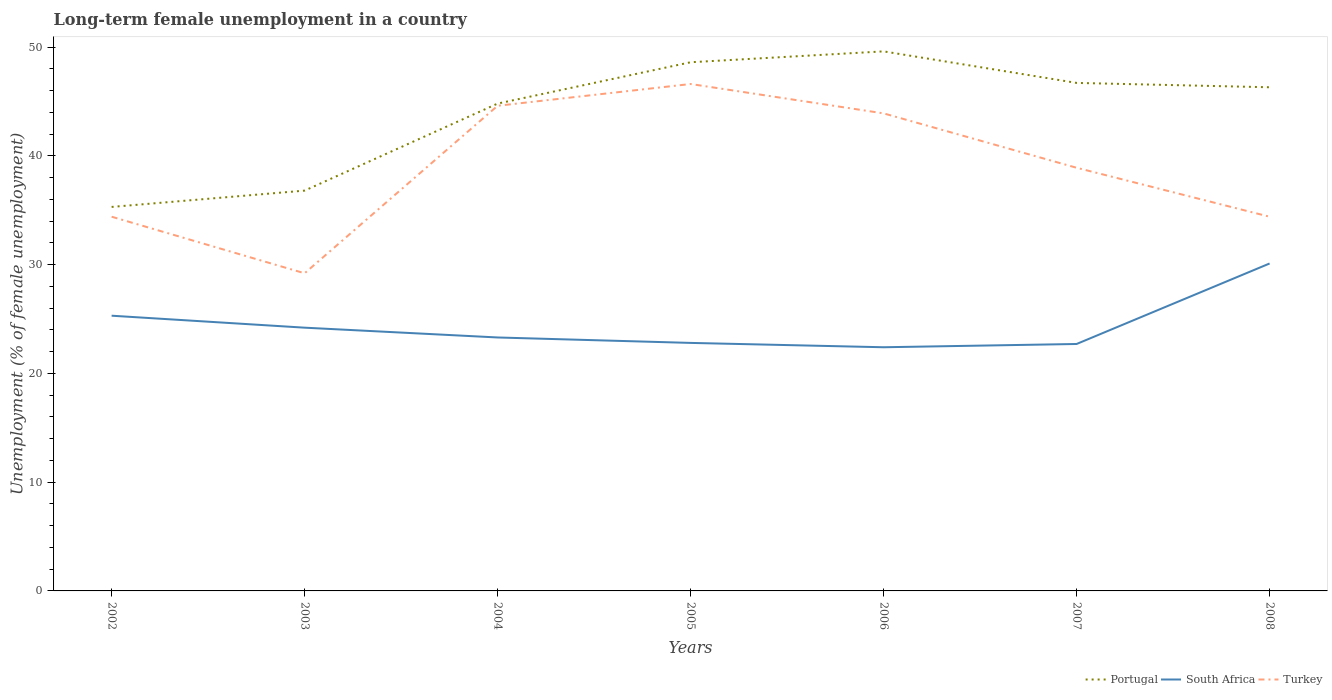Is the number of lines equal to the number of legend labels?
Offer a terse response. Yes. Across all years, what is the maximum percentage of long-term unemployed female population in Portugal?
Offer a terse response. 35.3. In which year was the percentage of long-term unemployed female population in Turkey maximum?
Make the answer very short. 2003. What is the total percentage of long-term unemployed female population in Turkey in the graph?
Keep it short and to the point. 5.7. What is the difference between the highest and the second highest percentage of long-term unemployed female population in South Africa?
Offer a terse response. 7.7. What is the difference between the highest and the lowest percentage of long-term unemployed female population in Turkey?
Offer a terse response. 4. How many lines are there?
Your answer should be very brief. 3. How many years are there in the graph?
Offer a very short reply. 7. What is the difference between two consecutive major ticks on the Y-axis?
Provide a short and direct response. 10. Does the graph contain any zero values?
Your answer should be very brief. No. How are the legend labels stacked?
Give a very brief answer. Horizontal. What is the title of the graph?
Ensure brevity in your answer.  Long-term female unemployment in a country. What is the label or title of the X-axis?
Offer a terse response. Years. What is the label or title of the Y-axis?
Provide a short and direct response. Unemployment (% of female unemployment). What is the Unemployment (% of female unemployment) of Portugal in 2002?
Give a very brief answer. 35.3. What is the Unemployment (% of female unemployment) in South Africa in 2002?
Your answer should be compact. 25.3. What is the Unemployment (% of female unemployment) of Turkey in 2002?
Ensure brevity in your answer.  34.4. What is the Unemployment (% of female unemployment) in Portugal in 2003?
Your answer should be compact. 36.8. What is the Unemployment (% of female unemployment) of South Africa in 2003?
Provide a short and direct response. 24.2. What is the Unemployment (% of female unemployment) in Turkey in 2003?
Provide a succinct answer. 29.2. What is the Unemployment (% of female unemployment) in Portugal in 2004?
Your answer should be compact. 44.8. What is the Unemployment (% of female unemployment) in South Africa in 2004?
Offer a terse response. 23.3. What is the Unemployment (% of female unemployment) of Turkey in 2004?
Provide a succinct answer. 44.6. What is the Unemployment (% of female unemployment) of Portugal in 2005?
Provide a short and direct response. 48.6. What is the Unemployment (% of female unemployment) in South Africa in 2005?
Offer a terse response. 22.8. What is the Unemployment (% of female unemployment) of Turkey in 2005?
Offer a terse response. 46.6. What is the Unemployment (% of female unemployment) of Portugal in 2006?
Your response must be concise. 49.6. What is the Unemployment (% of female unemployment) in South Africa in 2006?
Keep it short and to the point. 22.4. What is the Unemployment (% of female unemployment) in Turkey in 2006?
Keep it short and to the point. 43.9. What is the Unemployment (% of female unemployment) in Portugal in 2007?
Make the answer very short. 46.7. What is the Unemployment (% of female unemployment) in South Africa in 2007?
Your response must be concise. 22.7. What is the Unemployment (% of female unemployment) in Turkey in 2007?
Your answer should be compact. 38.9. What is the Unemployment (% of female unemployment) in Portugal in 2008?
Give a very brief answer. 46.3. What is the Unemployment (% of female unemployment) of South Africa in 2008?
Provide a succinct answer. 30.1. What is the Unemployment (% of female unemployment) in Turkey in 2008?
Give a very brief answer. 34.4. Across all years, what is the maximum Unemployment (% of female unemployment) of Portugal?
Your answer should be compact. 49.6. Across all years, what is the maximum Unemployment (% of female unemployment) of South Africa?
Ensure brevity in your answer.  30.1. Across all years, what is the maximum Unemployment (% of female unemployment) in Turkey?
Your answer should be compact. 46.6. Across all years, what is the minimum Unemployment (% of female unemployment) in Portugal?
Offer a terse response. 35.3. Across all years, what is the minimum Unemployment (% of female unemployment) of South Africa?
Give a very brief answer. 22.4. Across all years, what is the minimum Unemployment (% of female unemployment) in Turkey?
Provide a succinct answer. 29.2. What is the total Unemployment (% of female unemployment) of Portugal in the graph?
Offer a very short reply. 308.1. What is the total Unemployment (% of female unemployment) of South Africa in the graph?
Keep it short and to the point. 170.8. What is the total Unemployment (% of female unemployment) of Turkey in the graph?
Provide a succinct answer. 272. What is the difference between the Unemployment (% of female unemployment) of South Africa in 2002 and that in 2003?
Provide a succinct answer. 1.1. What is the difference between the Unemployment (% of female unemployment) of Turkey in 2002 and that in 2004?
Give a very brief answer. -10.2. What is the difference between the Unemployment (% of female unemployment) in Portugal in 2002 and that in 2005?
Offer a very short reply. -13.3. What is the difference between the Unemployment (% of female unemployment) of South Africa in 2002 and that in 2005?
Ensure brevity in your answer.  2.5. What is the difference between the Unemployment (% of female unemployment) in Portugal in 2002 and that in 2006?
Keep it short and to the point. -14.3. What is the difference between the Unemployment (% of female unemployment) in Portugal in 2002 and that in 2007?
Provide a short and direct response. -11.4. What is the difference between the Unemployment (% of female unemployment) in South Africa in 2002 and that in 2007?
Provide a short and direct response. 2.6. What is the difference between the Unemployment (% of female unemployment) of Turkey in 2002 and that in 2007?
Your response must be concise. -4.5. What is the difference between the Unemployment (% of female unemployment) in South Africa in 2002 and that in 2008?
Your answer should be very brief. -4.8. What is the difference between the Unemployment (% of female unemployment) in South Africa in 2003 and that in 2004?
Give a very brief answer. 0.9. What is the difference between the Unemployment (% of female unemployment) in Turkey in 2003 and that in 2004?
Give a very brief answer. -15.4. What is the difference between the Unemployment (% of female unemployment) in Turkey in 2003 and that in 2005?
Offer a very short reply. -17.4. What is the difference between the Unemployment (% of female unemployment) in Portugal in 2003 and that in 2006?
Give a very brief answer. -12.8. What is the difference between the Unemployment (% of female unemployment) in Turkey in 2003 and that in 2006?
Offer a terse response. -14.7. What is the difference between the Unemployment (% of female unemployment) in Portugal in 2003 and that in 2007?
Provide a succinct answer. -9.9. What is the difference between the Unemployment (% of female unemployment) of South Africa in 2003 and that in 2008?
Give a very brief answer. -5.9. What is the difference between the Unemployment (% of female unemployment) in Turkey in 2003 and that in 2008?
Your answer should be very brief. -5.2. What is the difference between the Unemployment (% of female unemployment) in Portugal in 2004 and that in 2005?
Make the answer very short. -3.8. What is the difference between the Unemployment (% of female unemployment) in Portugal in 2004 and that in 2006?
Provide a succinct answer. -4.8. What is the difference between the Unemployment (% of female unemployment) of Portugal in 2004 and that in 2008?
Make the answer very short. -1.5. What is the difference between the Unemployment (% of female unemployment) of Turkey in 2004 and that in 2008?
Make the answer very short. 10.2. What is the difference between the Unemployment (% of female unemployment) in Portugal in 2005 and that in 2006?
Your response must be concise. -1. What is the difference between the Unemployment (% of female unemployment) in Turkey in 2005 and that in 2006?
Offer a terse response. 2.7. What is the difference between the Unemployment (% of female unemployment) of Portugal in 2005 and that in 2007?
Your answer should be compact. 1.9. What is the difference between the Unemployment (% of female unemployment) in South Africa in 2005 and that in 2007?
Provide a short and direct response. 0.1. What is the difference between the Unemployment (% of female unemployment) of Turkey in 2005 and that in 2007?
Ensure brevity in your answer.  7.7. What is the difference between the Unemployment (% of female unemployment) in South Africa in 2005 and that in 2008?
Make the answer very short. -7.3. What is the difference between the Unemployment (% of female unemployment) of Portugal in 2006 and that in 2007?
Keep it short and to the point. 2.9. What is the difference between the Unemployment (% of female unemployment) in Portugal in 2006 and that in 2008?
Make the answer very short. 3.3. What is the difference between the Unemployment (% of female unemployment) of South Africa in 2006 and that in 2008?
Make the answer very short. -7.7. What is the difference between the Unemployment (% of female unemployment) of Turkey in 2006 and that in 2008?
Give a very brief answer. 9.5. What is the difference between the Unemployment (% of female unemployment) in South Africa in 2007 and that in 2008?
Provide a short and direct response. -7.4. What is the difference between the Unemployment (% of female unemployment) in Turkey in 2007 and that in 2008?
Provide a succinct answer. 4.5. What is the difference between the Unemployment (% of female unemployment) of Portugal in 2002 and the Unemployment (% of female unemployment) of South Africa in 2004?
Ensure brevity in your answer.  12. What is the difference between the Unemployment (% of female unemployment) of Portugal in 2002 and the Unemployment (% of female unemployment) of Turkey in 2004?
Provide a succinct answer. -9.3. What is the difference between the Unemployment (% of female unemployment) of South Africa in 2002 and the Unemployment (% of female unemployment) of Turkey in 2004?
Keep it short and to the point. -19.3. What is the difference between the Unemployment (% of female unemployment) of Portugal in 2002 and the Unemployment (% of female unemployment) of South Africa in 2005?
Provide a short and direct response. 12.5. What is the difference between the Unemployment (% of female unemployment) in Portugal in 2002 and the Unemployment (% of female unemployment) in Turkey in 2005?
Your answer should be compact. -11.3. What is the difference between the Unemployment (% of female unemployment) in South Africa in 2002 and the Unemployment (% of female unemployment) in Turkey in 2005?
Provide a succinct answer. -21.3. What is the difference between the Unemployment (% of female unemployment) of South Africa in 2002 and the Unemployment (% of female unemployment) of Turkey in 2006?
Give a very brief answer. -18.6. What is the difference between the Unemployment (% of female unemployment) of Portugal in 2002 and the Unemployment (% of female unemployment) of Turkey in 2007?
Your response must be concise. -3.6. What is the difference between the Unemployment (% of female unemployment) in South Africa in 2002 and the Unemployment (% of female unemployment) in Turkey in 2007?
Offer a very short reply. -13.6. What is the difference between the Unemployment (% of female unemployment) of Portugal in 2002 and the Unemployment (% of female unemployment) of South Africa in 2008?
Your answer should be very brief. 5.2. What is the difference between the Unemployment (% of female unemployment) in Portugal in 2003 and the Unemployment (% of female unemployment) in Turkey in 2004?
Offer a very short reply. -7.8. What is the difference between the Unemployment (% of female unemployment) of South Africa in 2003 and the Unemployment (% of female unemployment) of Turkey in 2004?
Keep it short and to the point. -20.4. What is the difference between the Unemployment (% of female unemployment) of Portugal in 2003 and the Unemployment (% of female unemployment) of South Africa in 2005?
Provide a short and direct response. 14. What is the difference between the Unemployment (% of female unemployment) in South Africa in 2003 and the Unemployment (% of female unemployment) in Turkey in 2005?
Give a very brief answer. -22.4. What is the difference between the Unemployment (% of female unemployment) in Portugal in 2003 and the Unemployment (% of female unemployment) in South Africa in 2006?
Offer a terse response. 14.4. What is the difference between the Unemployment (% of female unemployment) of South Africa in 2003 and the Unemployment (% of female unemployment) of Turkey in 2006?
Your answer should be very brief. -19.7. What is the difference between the Unemployment (% of female unemployment) of Portugal in 2003 and the Unemployment (% of female unemployment) of South Africa in 2007?
Your answer should be compact. 14.1. What is the difference between the Unemployment (% of female unemployment) in Portugal in 2003 and the Unemployment (% of female unemployment) in Turkey in 2007?
Keep it short and to the point. -2.1. What is the difference between the Unemployment (% of female unemployment) in South Africa in 2003 and the Unemployment (% of female unemployment) in Turkey in 2007?
Your answer should be compact. -14.7. What is the difference between the Unemployment (% of female unemployment) of Portugal in 2004 and the Unemployment (% of female unemployment) of Turkey in 2005?
Provide a succinct answer. -1.8. What is the difference between the Unemployment (% of female unemployment) of South Africa in 2004 and the Unemployment (% of female unemployment) of Turkey in 2005?
Give a very brief answer. -23.3. What is the difference between the Unemployment (% of female unemployment) in Portugal in 2004 and the Unemployment (% of female unemployment) in South Africa in 2006?
Offer a very short reply. 22.4. What is the difference between the Unemployment (% of female unemployment) in Portugal in 2004 and the Unemployment (% of female unemployment) in Turkey in 2006?
Provide a short and direct response. 0.9. What is the difference between the Unemployment (% of female unemployment) of South Africa in 2004 and the Unemployment (% of female unemployment) of Turkey in 2006?
Offer a terse response. -20.6. What is the difference between the Unemployment (% of female unemployment) in Portugal in 2004 and the Unemployment (% of female unemployment) in South Africa in 2007?
Your answer should be compact. 22.1. What is the difference between the Unemployment (% of female unemployment) in South Africa in 2004 and the Unemployment (% of female unemployment) in Turkey in 2007?
Offer a very short reply. -15.6. What is the difference between the Unemployment (% of female unemployment) of South Africa in 2004 and the Unemployment (% of female unemployment) of Turkey in 2008?
Keep it short and to the point. -11.1. What is the difference between the Unemployment (% of female unemployment) of Portugal in 2005 and the Unemployment (% of female unemployment) of South Africa in 2006?
Your answer should be compact. 26.2. What is the difference between the Unemployment (% of female unemployment) of Portugal in 2005 and the Unemployment (% of female unemployment) of Turkey in 2006?
Keep it short and to the point. 4.7. What is the difference between the Unemployment (% of female unemployment) in South Africa in 2005 and the Unemployment (% of female unemployment) in Turkey in 2006?
Make the answer very short. -21.1. What is the difference between the Unemployment (% of female unemployment) in Portugal in 2005 and the Unemployment (% of female unemployment) in South Africa in 2007?
Ensure brevity in your answer.  25.9. What is the difference between the Unemployment (% of female unemployment) of South Africa in 2005 and the Unemployment (% of female unemployment) of Turkey in 2007?
Keep it short and to the point. -16.1. What is the difference between the Unemployment (% of female unemployment) of Portugal in 2005 and the Unemployment (% of female unemployment) of Turkey in 2008?
Provide a succinct answer. 14.2. What is the difference between the Unemployment (% of female unemployment) of Portugal in 2006 and the Unemployment (% of female unemployment) of South Africa in 2007?
Make the answer very short. 26.9. What is the difference between the Unemployment (% of female unemployment) of South Africa in 2006 and the Unemployment (% of female unemployment) of Turkey in 2007?
Make the answer very short. -16.5. What is the difference between the Unemployment (% of female unemployment) in Portugal in 2006 and the Unemployment (% of female unemployment) in South Africa in 2008?
Give a very brief answer. 19.5. What is the difference between the Unemployment (% of female unemployment) of Portugal in 2006 and the Unemployment (% of female unemployment) of Turkey in 2008?
Offer a very short reply. 15.2. What is the difference between the Unemployment (% of female unemployment) in Portugal in 2007 and the Unemployment (% of female unemployment) in South Africa in 2008?
Make the answer very short. 16.6. What is the difference between the Unemployment (% of female unemployment) in Portugal in 2007 and the Unemployment (% of female unemployment) in Turkey in 2008?
Offer a terse response. 12.3. What is the average Unemployment (% of female unemployment) in Portugal per year?
Keep it short and to the point. 44.01. What is the average Unemployment (% of female unemployment) in South Africa per year?
Ensure brevity in your answer.  24.4. What is the average Unemployment (% of female unemployment) in Turkey per year?
Provide a succinct answer. 38.86. In the year 2002, what is the difference between the Unemployment (% of female unemployment) in Portugal and Unemployment (% of female unemployment) in South Africa?
Your answer should be compact. 10. In the year 2002, what is the difference between the Unemployment (% of female unemployment) of Portugal and Unemployment (% of female unemployment) of Turkey?
Your response must be concise. 0.9. In the year 2004, what is the difference between the Unemployment (% of female unemployment) of Portugal and Unemployment (% of female unemployment) of South Africa?
Offer a terse response. 21.5. In the year 2004, what is the difference between the Unemployment (% of female unemployment) of South Africa and Unemployment (% of female unemployment) of Turkey?
Provide a short and direct response. -21.3. In the year 2005, what is the difference between the Unemployment (% of female unemployment) in Portugal and Unemployment (% of female unemployment) in South Africa?
Your answer should be compact. 25.8. In the year 2005, what is the difference between the Unemployment (% of female unemployment) in Portugal and Unemployment (% of female unemployment) in Turkey?
Offer a very short reply. 2. In the year 2005, what is the difference between the Unemployment (% of female unemployment) of South Africa and Unemployment (% of female unemployment) of Turkey?
Offer a very short reply. -23.8. In the year 2006, what is the difference between the Unemployment (% of female unemployment) in Portugal and Unemployment (% of female unemployment) in South Africa?
Ensure brevity in your answer.  27.2. In the year 2006, what is the difference between the Unemployment (% of female unemployment) of South Africa and Unemployment (% of female unemployment) of Turkey?
Make the answer very short. -21.5. In the year 2007, what is the difference between the Unemployment (% of female unemployment) in Portugal and Unemployment (% of female unemployment) in South Africa?
Ensure brevity in your answer.  24. In the year 2007, what is the difference between the Unemployment (% of female unemployment) of Portugal and Unemployment (% of female unemployment) of Turkey?
Give a very brief answer. 7.8. In the year 2007, what is the difference between the Unemployment (% of female unemployment) of South Africa and Unemployment (% of female unemployment) of Turkey?
Your response must be concise. -16.2. In the year 2008, what is the difference between the Unemployment (% of female unemployment) of Portugal and Unemployment (% of female unemployment) of South Africa?
Your answer should be compact. 16.2. In the year 2008, what is the difference between the Unemployment (% of female unemployment) in Portugal and Unemployment (% of female unemployment) in Turkey?
Your response must be concise. 11.9. In the year 2008, what is the difference between the Unemployment (% of female unemployment) in South Africa and Unemployment (% of female unemployment) in Turkey?
Give a very brief answer. -4.3. What is the ratio of the Unemployment (% of female unemployment) in Portugal in 2002 to that in 2003?
Ensure brevity in your answer.  0.96. What is the ratio of the Unemployment (% of female unemployment) of South Africa in 2002 to that in 2003?
Keep it short and to the point. 1.05. What is the ratio of the Unemployment (% of female unemployment) in Turkey in 2002 to that in 2003?
Your answer should be compact. 1.18. What is the ratio of the Unemployment (% of female unemployment) in Portugal in 2002 to that in 2004?
Provide a short and direct response. 0.79. What is the ratio of the Unemployment (% of female unemployment) in South Africa in 2002 to that in 2004?
Ensure brevity in your answer.  1.09. What is the ratio of the Unemployment (% of female unemployment) of Turkey in 2002 to that in 2004?
Your response must be concise. 0.77. What is the ratio of the Unemployment (% of female unemployment) in Portugal in 2002 to that in 2005?
Offer a terse response. 0.73. What is the ratio of the Unemployment (% of female unemployment) in South Africa in 2002 to that in 2005?
Offer a terse response. 1.11. What is the ratio of the Unemployment (% of female unemployment) in Turkey in 2002 to that in 2005?
Keep it short and to the point. 0.74. What is the ratio of the Unemployment (% of female unemployment) of Portugal in 2002 to that in 2006?
Give a very brief answer. 0.71. What is the ratio of the Unemployment (% of female unemployment) of South Africa in 2002 to that in 2006?
Offer a very short reply. 1.13. What is the ratio of the Unemployment (% of female unemployment) of Turkey in 2002 to that in 2006?
Provide a short and direct response. 0.78. What is the ratio of the Unemployment (% of female unemployment) of Portugal in 2002 to that in 2007?
Your answer should be compact. 0.76. What is the ratio of the Unemployment (% of female unemployment) of South Africa in 2002 to that in 2007?
Offer a very short reply. 1.11. What is the ratio of the Unemployment (% of female unemployment) of Turkey in 2002 to that in 2007?
Provide a short and direct response. 0.88. What is the ratio of the Unemployment (% of female unemployment) of Portugal in 2002 to that in 2008?
Your answer should be compact. 0.76. What is the ratio of the Unemployment (% of female unemployment) in South Africa in 2002 to that in 2008?
Provide a succinct answer. 0.84. What is the ratio of the Unemployment (% of female unemployment) of Turkey in 2002 to that in 2008?
Make the answer very short. 1. What is the ratio of the Unemployment (% of female unemployment) of Portugal in 2003 to that in 2004?
Give a very brief answer. 0.82. What is the ratio of the Unemployment (% of female unemployment) in South Africa in 2003 to that in 2004?
Provide a short and direct response. 1.04. What is the ratio of the Unemployment (% of female unemployment) in Turkey in 2003 to that in 2004?
Keep it short and to the point. 0.65. What is the ratio of the Unemployment (% of female unemployment) of Portugal in 2003 to that in 2005?
Ensure brevity in your answer.  0.76. What is the ratio of the Unemployment (% of female unemployment) in South Africa in 2003 to that in 2005?
Provide a short and direct response. 1.06. What is the ratio of the Unemployment (% of female unemployment) in Turkey in 2003 to that in 2005?
Offer a terse response. 0.63. What is the ratio of the Unemployment (% of female unemployment) of Portugal in 2003 to that in 2006?
Your response must be concise. 0.74. What is the ratio of the Unemployment (% of female unemployment) in South Africa in 2003 to that in 2006?
Keep it short and to the point. 1.08. What is the ratio of the Unemployment (% of female unemployment) in Turkey in 2003 to that in 2006?
Provide a succinct answer. 0.67. What is the ratio of the Unemployment (% of female unemployment) of Portugal in 2003 to that in 2007?
Make the answer very short. 0.79. What is the ratio of the Unemployment (% of female unemployment) of South Africa in 2003 to that in 2007?
Ensure brevity in your answer.  1.07. What is the ratio of the Unemployment (% of female unemployment) in Turkey in 2003 to that in 2007?
Offer a very short reply. 0.75. What is the ratio of the Unemployment (% of female unemployment) in Portugal in 2003 to that in 2008?
Provide a succinct answer. 0.79. What is the ratio of the Unemployment (% of female unemployment) in South Africa in 2003 to that in 2008?
Ensure brevity in your answer.  0.8. What is the ratio of the Unemployment (% of female unemployment) of Turkey in 2003 to that in 2008?
Give a very brief answer. 0.85. What is the ratio of the Unemployment (% of female unemployment) in Portugal in 2004 to that in 2005?
Offer a terse response. 0.92. What is the ratio of the Unemployment (% of female unemployment) in South Africa in 2004 to that in 2005?
Offer a terse response. 1.02. What is the ratio of the Unemployment (% of female unemployment) of Turkey in 2004 to that in 2005?
Provide a short and direct response. 0.96. What is the ratio of the Unemployment (% of female unemployment) of Portugal in 2004 to that in 2006?
Your answer should be very brief. 0.9. What is the ratio of the Unemployment (% of female unemployment) in South Africa in 2004 to that in 2006?
Provide a succinct answer. 1.04. What is the ratio of the Unemployment (% of female unemployment) in Turkey in 2004 to that in 2006?
Give a very brief answer. 1.02. What is the ratio of the Unemployment (% of female unemployment) of Portugal in 2004 to that in 2007?
Offer a very short reply. 0.96. What is the ratio of the Unemployment (% of female unemployment) in South Africa in 2004 to that in 2007?
Provide a short and direct response. 1.03. What is the ratio of the Unemployment (% of female unemployment) of Turkey in 2004 to that in 2007?
Offer a terse response. 1.15. What is the ratio of the Unemployment (% of female unemployment) in Portugal in 2004 to that in 2008?
Provide a succinct answer. 0.97. What is the ratio of the Unemployment (% of female unemployment) of South Africa in 2004 to that in 2008?
Provide a short and direct response. 0.77. What is the ratio of the Unemployment (% of female unemployment) in Turkey in 2004 to that in 2008?
Your response must be concise. 1.3. What is the ratio of the Unemployment (% of female unemployment) of Portugal in 2005 to that in 2006?
Keep it short and to the point. 0.98. What is the ratio of the Unemployment (% of female unemployment) in South Africa in 2005 to that in 2006?
Your response must be concise. 1.02. What is the ratio of the Unemployment (% of female unemployment) of Turkey in 2005 to that in 2006?
Ensure brevity in your answer.  1.06. What is the ratio of the Unemployment (% of female unemployment) in Portugal in 2005 to that in 2007?
Your answer should be compact. 1.04. What is the ratio of the Unemployment (% of female unemployment) of South Africa in 2005 to that in 2007?
Offer a terse response. 1. What is the ratio of the Unemployment (% of female unemployment) in Turkey in 2005 to that in 2007?
Keep it short and to the point. 1.2. What is the ratio of the Unemployment (% of female unemployment) in Portugal in 2005 to that in 2008?
Your answer should be very brief. 1.05. What is the ratio of the Unemployment (% of female unemployment) of South Africa in 2005 to that in 2008?
Your answer should be very brief. 0.76. What is the ratio of the Unemployment (% of female unemployment) in Turkey in 2005 to that in 2008?
Provide a succinct answer. 1.35. What is the ratio of the Unemployment (% of female unemployment) in Portugal in 2006 to that in 2007?
Give a very brief answer. 1.06. What is the ratio of the Unemployment (% of female unemployment) in South Africa in 2006 to that in 2007?
Give a very brief answer. 0.99. What is the ratio of the Unemployment (% of female unemployment) of Turkey in 2006 to that in 2007?
Your response must be concise. 1.13. What is the ratio of the Unemployment (% of female unemployment) in Portugal in 2006 to that in 2008?
Your response must be concise. 1.07. What is the ratio of the Unemployment (% of female unemployment) in South Africa in 2006 to that in 2008?
Your answer should be compact. 0.74. What is the ratio of the Unemployment (% of female unemployment) of Turkey in 2006 to that in 2008?
Your response must be concise. 1.28. What is the ratio of the Unemployment (% of female unemployment) of Portugal in 2007 to that in 2008?
Your response must be concise. 1.01. What is the ratio of the Unemployment (% of female unemployment) in South Africa in 2007 to that in 2008?
Make the answer very short. 0.75. What is the ratio of the Unemployment (% of female unemployment) of Turkey in 2007 to that in 2008?
Your answer should be compact. 1.13. What is the difference between the highest and the second highest Unemployment (% of female unemployment) in Portugal?
Your response must be concise. 1. What is the difference between the highest and the lowest Unemployment (% of female unemployment) of Portugal?
Provide a short and direct response. 14.3. 